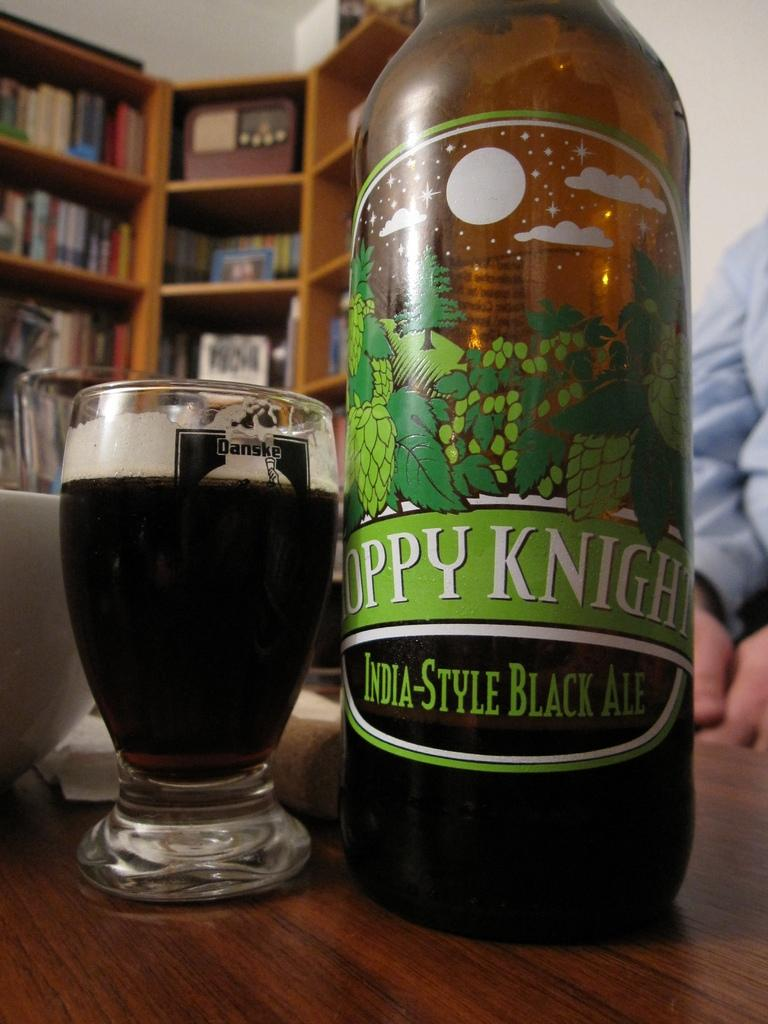<image>
Summarize the visual content of the image. India-Style Ale bottle and India-Style ale poured in a Danske glass. 